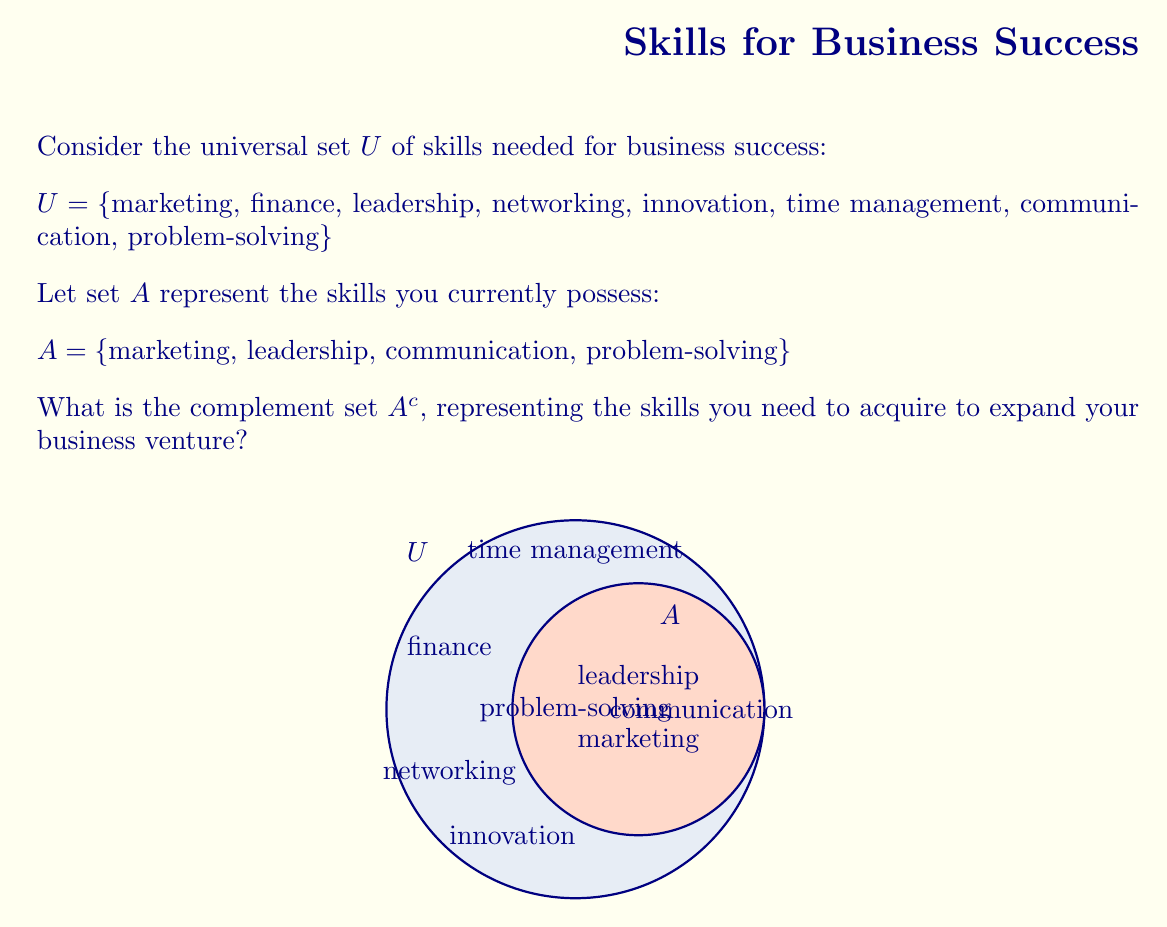Can you solve this math problem? To find the complement set $A^c$, we need to identify all elements in the universal set $U$ that are not in set $A$. 

Step 1: Identify elements in $U$:
$U = \{$marketing, finance, leadership, networking, innovation, time management, communication, problem-solving$\}$

Step 2: Identify elements in $A$:
$A = \{$marketing, leadership, communication, problem-solving$\}$

Step 3: Find elements in $U$ that are not in $A$:
- finance
- networking
- innovation
- time management

Step 4: Write the complement set $A^c$:
$A^c = \{$finance, networking, innovation, time management$\}$

This set represents the skills you need to acquire to expand your business venture.
Answer: $A^c = \{$finance, networking, innovation, time management$\}$ 